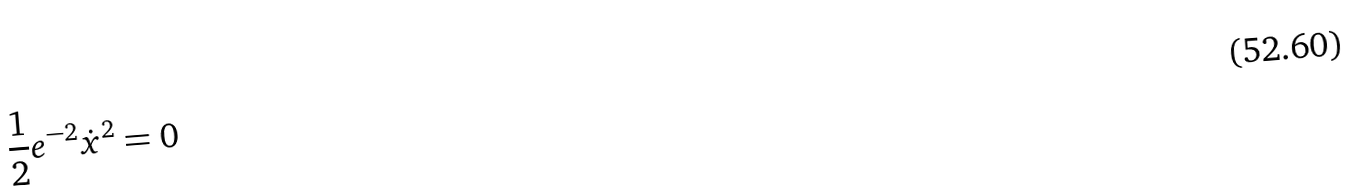<formula> <loc_0><loc_0><loc_500><loc_500>\frac { 1 } { 2 } e ^ { - 2 } \dot { x } ^ { 2 } = 0</formula> 